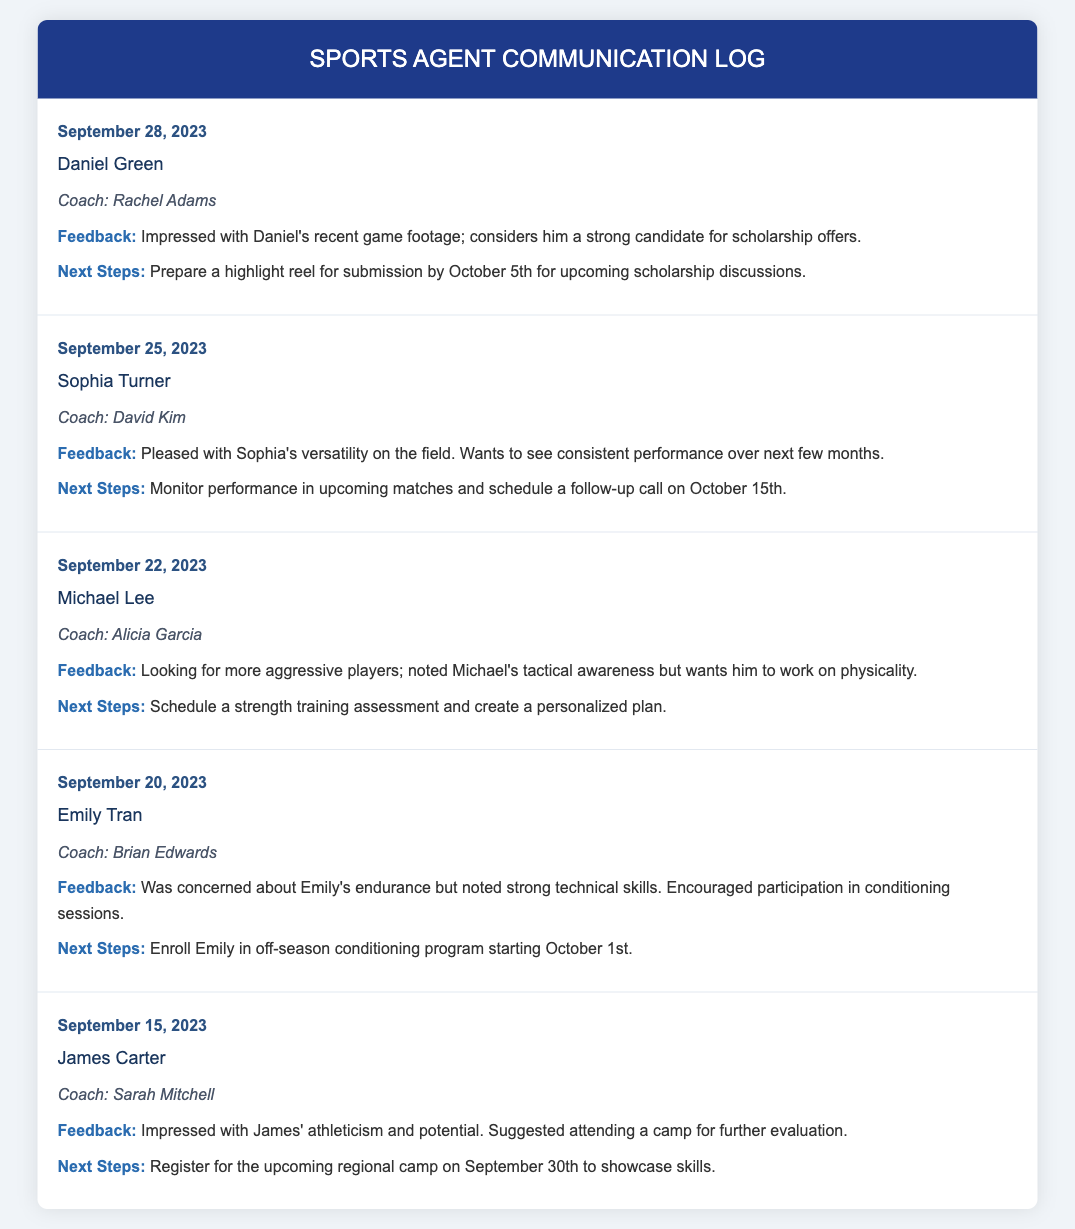What is the date of Daniel Green's feedback? Daniel Green's feedback was logged on September 28, 2023.
Answer: September 28, 2023 Who is the coach for Sophia Turner? The log states that Sophia Turner's coach is David Kim.
Answer: David Kim What is the next step for Michael Lee? The next step for Michael Lee is to schedule a strength training assessment and create a personalized plan.
Answer: Schedule a strength training assessment What feedback did Coach Brian Edwards provide about Emily Tran? Coach Brian Edwards noted concerns about Emily's endurance but recognized her strong technical skills.
Answer: Concerns about endurance When is the follow-up call scheduled for Sophia Turner? The follow-up call for Sophia Turner is scheduled on October 15th.
Answer: October 15th What is the reason Coach Rachel Adams is impressed with Daniel Green? Coach Rachel Adams is impressed with Daniel's recent game footage and considers him a strong candidate for scholarship offers.
Answer: Recent game footage What did Coach Sarah Mitchell suggest for James Carter? Coach Sarah Mitchell suggested James attend a camp for further evaluation of his athleticism and potential.
Answer: Attend a camp What is the feedback regarding Michael Lee's physicality? The feedback states that Coach Alicia Garcia wants Michael to work on his physicality.
Answer: Work on physicality 